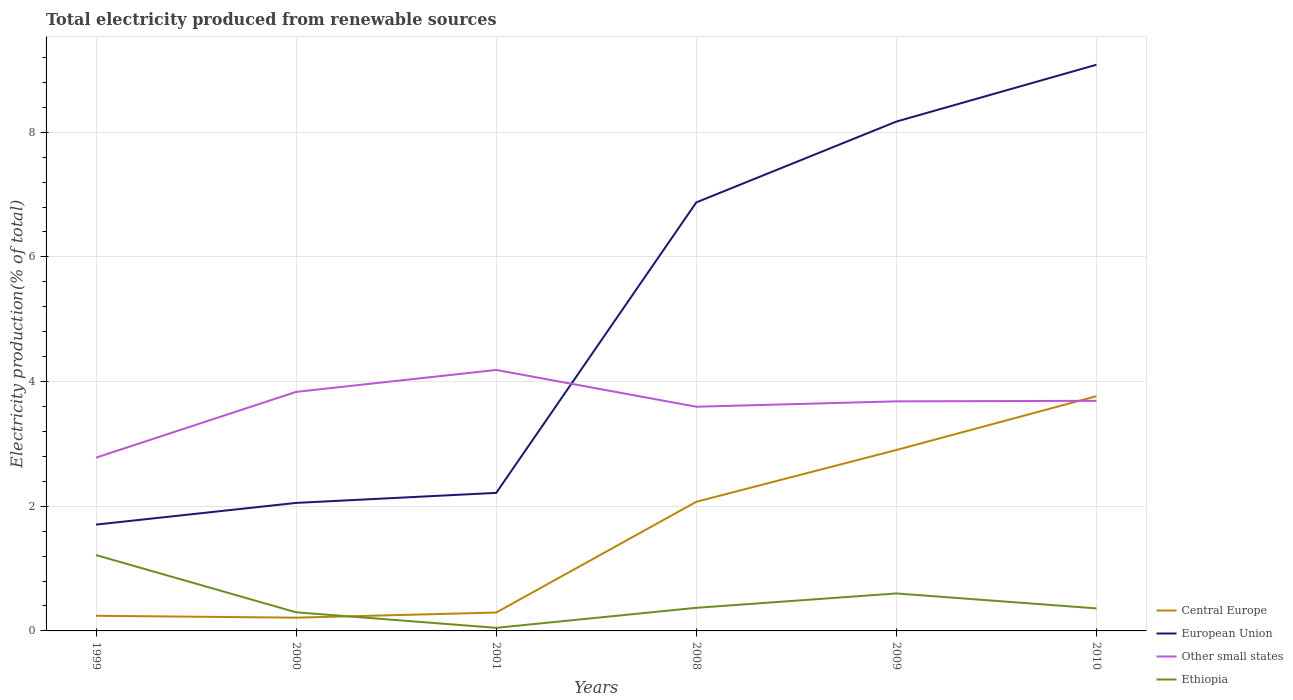How many different coloured lines are there?
Your answer should be compact. 4. Does the line corresponding to Other small states intersect with the line corresponding to Central Europe?
Your answer should be very brief. Yes. Across all years, what is the maximum total electricity produced in Ethiopia?
Keep it short and to the point. 0.05. In which year was the total electricity produced in Ethiopia maximum?
Your response must be concise. 2001. What is the total total electricity produced in Other small states in the graph?
Your answer should be compact. 0.15. What is the difference between the highest and the second highest total electricity produced in Other small states?
Provide a short and direct response. 1.41. What is the difference between the highest and the lowest total electricity produced in European Union?
Provide a succinct answer. 3. Is the total electricity produced in Ethiopia strictly greater than the total electricity produced in European Union over the years?
Offer a terse response. Yes. Are the values on the major ticks of Y-axis written in scientific E-notation?
Provide a short and direct response. No. Does the graph contain grids?
Provide a succinct answer. Yes. What is the title of the graph?
Keep it short and to the point. Total electricity produced from renewable sources. What is the label or title of the X-axis?
Offer a terse response. Years. What is the label or title of the Y-axis?
Keep it short and to the point. Electricity production(% of total). What is the Electricity production(% of total) of Central Europe in 1999?
Offer a very short reply. 0.24. What is the Electricity production(% of total) in European Union in 1999?
Make the answer very short. 1.71. What is the Electricity production(% of total) in Other small states in 1999?
Your response must be concise. 2.78. What is the Electricity production(% of total) in Ethiopia in 1999?
Your answer should be compact. 1.22. What is the Electricity production(% of total) in Central Europe in 2000?
Your answer should be compact. 0.21. What is the Electricity production(% of total) of European Union in 2000?
Your answer should be compact. 2.05. What is the Electricity production(% of total) of Other small states in 2000?
Provide a succinct answer. 3.83. What is the Electricity production(% of total) of Ethiopia in 2000?
Offer a very short reply. 0.3. What is the Electricity production(% of total) in Central Europe in 2001?
Give a very brief answer. 0.29. What is the Electricity production(% of total) of European Union in 2001?
Offer a terse response. 2.21. What is the Electricity production(% of total) of Other small states in 2001?
Your answer should be compact. 4.19. What is the Electricity production(% of total) in Ethiopia in 2001?
Make the answer very short. 0.05. What is the Electricity production(% of total) in Central Europe in 2008?
Provide a short and direct response. 2.07. What is the Electricity production(% of total) in European Union in 2008?
Your response must be concise. 6.87. What is the Electricity production(% of total) in Other small states in 2008?
Give a very brief answer. 3.6. What is the Electricity production(% of total) in Ethiopia in 2008?
Provide a short and direct response. 0.37. What is the Electricity production(% of total) in Central Europe in 2009?
Offer a very short reply. 2.9. What is the Electricity production(% of total) of European Union in 2009?
Give a very brief answer. 8.17. What is the Electricity production(% of total) in Other small states in 2009?
Your response must be concise. 3.68. What is the Electricity production(% of total) in Ethiopia in 2009?
Offer a very short reply. 0.6. What is the Electricity production(% of total) in Central Europe in 2010?
Your response must be concise. 3.77. What is the Electricity production(% of total) in European Union in 2010?
Ensure brevity in your answer.  9.08. What is the Electricity production(% of total) of Other small states in 2010?
Your answer should be compact. 3.69. What is the Electricity production(% of total) of Ethiopia in 2010?
Your answer should be very brief. 0.36. Across all years, what is the maximum Electricity production(% of total) of Central Europe?
Provide a short and direct response. 3.77. Across all years, what is the maximum Electricity production(% of total) in European Union?
Ensure brevity in your answer.  9.08. Across all years, what is the maximum Electricity production(% of total) of Other small states?
Offer a very short reply. 4.19. Across all years, what is the maximum Electricity production(% of total) in Ethiopia?
Give a very brief answer. 1.22. Across all years, what is the minimum Electricity production(% of total) in Central Europe?
Your response must be concise. 0.21. Across all years, what is the minimum Electricity production(% of total) in European Union?
Provide a succinct answer. 1.71. Across all years, what is the minimum Electricity production(% of total) of Other small states?
Ensure brevity in your answer.  2.78. Across all years, what is the minimum Electricity production(% of total) of Ethiopia?
Your response must be concise. 0.05. What is the total Electricity production(% of total) of Central Europe in the graph?
Provide a short and direct response. 9.49. What is the total Electricity production(% of total) of European Union in the graph?
Make the answer very short. 30.1. What is the total Electricity production(% of total) in Other small states in the graph?
Provide a short and direct response. 21.77. What is the total Electricity production(% of total) in Ethiopia in the graph?
Ensure brevity in your answer.  2.9. What is the difference between the Electricity production(% of total) in Central Europe in 1999 and that in 2000?
Provide a short and direct response. 0.03. What is the difference between the Electricity production(% of total) in European Union in 1999 and that in 2000?
Your answer should be compact. -0.35. What is the difference between the Electricity production(% of total) in Other small states in 1999 and that in 2000?
Provide a succinct answer. -1.06. What is the difference between the Electricity production(% of total) of Ethiopia in 1999 and that in 2000?
Ensure brevity in your answer.  0.92. What is the difference between the Electricity production(% of total) in Central Europe in 1999 and that in 2001?
Your response must be concise. -0.05. What is the difference between the Electricity production(% of total) of European Union in 1999 and that in 2001?
Keep it short and to the point. -0.51. What is the difference between the Electricity production(% of total) of Other small states in 1999 and that in 2001?
Your answer should be very brief. -1.41. What is the difference between the Electricity production(% of total) of Ethiopia in 1999 and that in 2001?
Provide a succinct answer. 1.17. What is the difference between the Electricity production(% of total) of Central Europe in 1999 and that in 2008?
Provide a succinct answer. -1.83. What is the difference between the Electricity production(% of total) of European Union in 1999 and that in 2008?
Provide a short and direct response. -5.17. What is the difference between the Electricity production(% of total) of Other small states in 1999 and that in 2008?
Ensure brevity in your answer.  -0.82. What is the difference between the Electricity production(% of total) of Ethiopia in 1999 and that in 2008?
Your response must be concise. 0.85. What is the difference between the Electricity production(% of total) of Central Europe in 1999 and that in 2009?
Make the answer very short. -2.66. What is the difference between the Electricity production(% of total) in European Union in 1999 and that in 2009?
Provide a succinct answer. -6.47. What is the difference between the Electricity production(% of total) of Other small states in 1999 and that in 2009?
Your answer should be very brief. -0.9. What is the difference between the Electricity production(% of total) of Ethiopia in 1999 and that in 2009?
Your answer should be compact. 0.62. What is the difference between the Electricity production(% of total) of Central Europe in 1999 and that in 2010?
Ensure brevity in your answer.  -3.52. What is the difference between the Electricity production(% of total) in European Union in 1999 and that in 2010?
Provide a succinct answer. -7.38. What is the difference between the Electricity production(% of total) of Other small states in 1999 and that in 2010?
Offer a very short reply. -0.91. What is the difference between the Electricity production(% of total) in Ethiopia in 1999 and that in 2010?
Offer a terse response. 0.86. What is the difference between the Electricity production(% of total) in Central Europe in 2000 and that in 2001?
Make the answer very short. -0.08. What is the difference between the Electricity production(% of total) of European Union in 2000 and that in 2001?
Keep it short and to the point. -0.16. What is the difference between the Electricity production(% of total) in Other small states in 2000 and that in 2001?
Offer a very short reply. -0.35. What is the difference between the Electricity production(% of total) of Ethiopia in 2000 and that in 2001?
Offer a terse response. 0.25. What is the difference between the Electricity production(% of total) of Central Europe in 2000 and that in 2008?
Your response must be concise. -1.86. What is the difference between the Electricity production(% of total) of European Union in 2000 and that in 2008?
Keep it short and to the point. -4.82. What is the difference between the Electricity production(% of total) in Other small states in 2000 and that in 2008?
Provide a succinct answer. 0.24. What is the difference between the Electricity production(% of total) of Ethiopia in 2000 and that in 2008?
Give a very brief answer. -0.07. What is the difference between the Electricity production(% of total) of Central Europe in 2000 and that in 2009?
Provide a short and direct response. -2.69. What is the difference between the Electricity production(% of total) of European Union in 2000 and that in 2009?
Provide a succinct answer. -6.12. What is the difference between the Electricity production(% of total) of Other small states in 2000 and that in 2009?
Your answer should be very brief. 0.15. What is the difference between the Electricity production(% of total) in Ethiopia in 2000 and that in 2009?
Offer a terse response. -0.3. What is the difference between the Electricity production(% of total) of Central Europe in 2000 and that in 2010?
Offer a terse response. -3.55. What is the difference between the Electricity production(% of total) in European Union in 2000 and that in 2010?
Offer a terse response. -7.03. What is the difference between the Electricity production(% of total) in Other small states in 2000 and that in 2010?
Keep it short and to the point. 0.14. What is the difference between the Electricity production(% of total) in Ethiopia in 2000 and that in 2010?
Offer a terse response. -0.06. What is the difference between the Electricity production(% of total) in Central Europe in 2001 and that in 2008?
Offer a terse response. -1.78. What is the difference between the Electricity production(% of total) of European Union in 2001 and that in 2008?
Provide a short and direct response. -4.66. What is the difference between the Electricity production(% of total) in Other small states in 2001 and that in 2008?
Offer a terse response. 0.59. What is the difference between the Electricity production(% of total) of Ethiopia in 2001 and that in 2008?
Make the answer very short. -0.32. What is the difference between the Electricity production(% of total) in Central Europe in 2001 and that in 2009?
Keep it short and to the point. -2.61. What is the difference between the Electricity production(% of total) in European Union in 2001 and that in 2009?
Make the answer very short. -5.96. What is the difference between the Electricity production(% of total) in Other small states in 2001 and that in 2009?
Give a very brief answer. 0.5. What is the difference between the Electricity production(% of total) of Ethiopia in 2001 and that in 2009?
Give a very brief answer. -0.55. What is the difference between the Electricity production(% of total) of Central Europe in 2001 and that in 2010?
Offer a very short reply. -3.47. What is the difference between the Electricity production(% of total) of European Union in 2001 and that in 2010?
Your answer should be very brief. -6.87. What is the difference between the Electricity production(% of total) in Other small states in 2001 and that in 2010?
Offer a very short reply. 0.49. What is the difference between the Electricity production(% of total) in Ethiopia in 2001 and that in 2010?
Your response must be concise. -0.31. What is the difference between the Electricity production(% of total) in Central Europe in 2008 and that in 2009?
Your answer should be very brief. -0.83. What is the difference between the Electricity production(% of total) of European Union in 2008 and that in 2009?
Offer a terse response. -1.3. What is the difference between the Electricity production(% of total) in Other small states in 2008 and that in 2009?
Offer a very short reply. -0.09. What is the difference between the Electricity production(% of total) in Ethiopia in 2008 and that in 2009?
Your answer should be compact. -0.23. What is the difference between the Electricity production(% of total) of Central Europe in 2008 and that in 2010?
Keep it short and to the point. -1.69. What is the difference between the Electricity production(% of total) of European Union in 2008 and that in 2010?
Offer a very short reply. -2.21. What is the difference between the Electricity production(% of total) in Other small states in 2008 and that in 2010?
Provide a short and direct response. -0.1. What is the difference between the Electricity production(% of total) of Ethiopia in 2008 and that in 2010?
Give a very brief answer. 0.01. What is the difference between the Electricity production(% of total) of Central Europe in 2009 and that in 2010?
Your response must be concise. -0.86. What is the difference between the Electricity production(% of total) in European Union in 2009 and that in 2010?
Provide a short and direct response. -0.91. What is the difference between the Electricity production(% of total) of Other small states in 2009 and that in 2010?
Offer a terse response. -0.01. What is the difference between the Electricity production(% of total) in Ethiopia in 2009 and that in 2010?
Your response must be concise. 0.24. What is the difference between the Electricity production(% of total) of Central Europe in 1999 and the Electricity production(% of total) of European Union in 2000?
Ensure brevity in your answer.  -1.81. What is the difference between the Electricity production(% of total) in Central Europe in 1999 and the Electricity production(% of total) in Other small states in 2000?
Keep it short and to the point. -3.59. What is the difference between the Electricity production(% of total) of Central Europe in 1999 and the Electricity production(% of total) of Ethiopia in 2000?
Ensure brevity in your answer.  -0.06. What is the difference between the Electricity production(% of total) in European Union in 1999 and the Electricity production(% of total) in Other small states in 2000?
Make the answer very short. -2.13. What is the difference between the Electricity production(% of total) in European Union in 1999 and the Electricity production(% of total) in Ethiopia in 2000?
Offer a terse response. 1.41. What is the difference between the Electricity production(% of total) of Other small states in 1999 and the Electricity production(% of total) of Ethiopia in 2000?
Provide a succinct answer. 2.48. What is the difference between the Electricity production(% of total) of Central Europe in 1999 and the Electricity production(% of total) of European Union in 2001?
Provide a succinct answer. -1.97. What is the difference between the Electricity production(% of total) in Central Europe in 1999 and the Electricity production(% of total) in Other small states in 2001?
Ensure brevity in your answer.  -3.94. What is the difference between the Electricity production(% of total) in Central Europe in 1999 and the Electricity production(% of total) in Ethiopia in 2001?
Your response must be concise. 0.19. What is the difference between the Electricity production(% of total) in European Union in 1999 and the Electricity production(% of total) in Other small states in 2001?
Ensure brevity in your answer.  -2.48. What is the difference between the Electricity production(% of total) of European Union in 1999 and the Electricity production(% of total) of Ethiopia in 2001?
Make the answer very short. 1.66. What is the difference between the Electricity production(% of total) in Other small states in 1999 and the Electricity production(% of total) in Ethiopia in 2001?
Provide a short and direct response. 2.73. What is the difference between the Electricity production(% of total) of Central Europe in 1999 and the Electricity production(% of total) of European Union in 2008?
Offer a very short reply. -6.63. What is the difference between the Electricity production(% of total) in Central Europe in 1999 and the Electricity production(% of total) in Other small states in 2008?
Ensure brevity in your answer.  -3.35. What is the difference between the Electricity production(% of total) of Central Europe in 1999 and the Electricity production(% of total) of Ethiopia in 2008?
Keep it short and to the point. -0.13. What is the difference between the Electricity production(% of total) of European Union in 1999 and the Electricity production(% of total) of Other small states in 2008?
Offer a very short reply. -1.89. What is the difference between the Electricity production(% of total) of European Union in 1999 and the Electricity production(% of total) of Ethiopia in 2008?
Your answer should be compact. 1.33. What is the difference between the Electricity production(% of total) of Other small states in 1999 and the Electricity production(% of total) of Ethiopia in 2008?
Your answer should be very brief. 2.41. What is the difference between the Electricity production(% of total) of Central Europe in 1999 and the Electricity production(% of total) of European Union in 2009?
Provide a succinct answer. -7.93. What is the difference between the Electricity production(% of total) in Central Europe in 1999 and the Electricity production(% of total) in Other small states in 2009?
Provide a succinct answer. -3.44. What is the difference between the Electricity production(% of total) of Central Europe in 1999 and the Electricity production(% of total) of Ethiopia in 2009?
Make the answer very short. -0.36. What is the difference between the Electricity production(% of total) of European Union in 1999 and the Electricity production(% of total) of Other small states in 2009?
Your response must be concise. -1.98. What is the difference between the Electricity production(% of total) of European Union in 1999 and the Electricity production(% of total) of Ethiopia in 2009?
Offer a terse response. 1.1. What is the difference between the Electricity production(% of total) of Other small states in 1999 and the Electricity production(% of total) of Ethiopia in 2009?
Offer a very short reply. 2.18. What is the difference between the Electricity production(% of total) of Central Europe in 1999 and the Electricity production(% of total) of European Union in 2010?
Offer a terse response. -8.84. What is the difference between the Electricity production(% of total) of Central Europe in 1999 and the Electricity production(% of total) of Other small states in 2010?
Keep it short and to the point. -3.45. What is the difference between the Electricity production(% of total) in Central Europe in 1999 and the Electricity production(% of total) in Ethiopia in 2010?
Provide a short and direct response. -0.12. What is the difference between the Electricity production(% of total) in European Union in 1999 and the Electricity production(% of total) in Other small states in 2010?
Provide a succinct answer. -1.99. What is the difference between the Electricity production(% of total) of European Union in 1999 and the Electricity production(% of total) of Ethiopia in 2010?
Provide a succinct answer. 1.34. What is the difference between the Electricity production(% of total) of Other small states in 1999 and the Electricity production(% of total) of Ethiopia in 2010?
Your answer should be compact. 2.42. What is the difference between the Electricity production(% of total) of Central Europe in 2000 and the Electricity production(% of total) of European Union in 2001?
Your answer should be very brief. -2. What is the difference between the Electricity production(% of total) in Central Europe in 2000 and the Electricity production(% of total) in Other small states in 2001?
Offer a very short reply. -3.97. What is the difference between the Electricity production(% of total) in Central Europe in 2000 and the Electricity production(% of total) in Ethiopia in 2001?
Keep it short and to the point. 0.16. What is the difference between the Electricity production(% of total) in European Union in 2000 and the Electricity production(% of total) in Other small states in 2001?
Your answer should be compact. -2.13. What is the difference between the Electricity production(% of total) of European Union in 2000 and the Electricity production(% of total) of Ethiopia in 2001?
Give a very brief answer. 2. What is the difference between the Electricity production(% of total) of Other small states in 2000 and the Electricity production(% of total) of Ethiopia in 2001?
Ensure brevity in your answer.  3.79. What is the difference between the Electricity production(% of total) of Central Europe in 2000 and the Electricity production(% of total) of European Union in 2008?
Keep it short and to the point. -6.66. What is the difference between the Electricity production(% of total) in Central Europe in 2000 and the Electricity production(% of total) in Other small states in 2008?
Make the answer very short. -3.38. What is the difference between the Electricity production(% of total) of Central Europe in 2000 and the Electricity production(% of total) of Ethiopia in 2008?
Make the answer very short. -0.16. What is the difference between the Electricity production(% of total) of European Union in 2000 and the Electricity production(% of total) of Other small states in 2008?
Give a very brief answer. -1.54. What is the difference between the Electricity production(% of total) of European Union in 2000 and the Electricity production(% of total) of Ethiopia in 2008?
Provide a succinct answer. 1.68. What is the difference between the Electricity production(% of total) in Other small states in 2000 and the Electricity production(% of total) in Ethiopia in 2008?
Your answer should be compact. 3.46. What is the difference between the Electricity production(% of total) of Central Europe in 2000 and the Electricity production(% of total) of European Union in 2009?
Make the answer very short. -7.96. What is the difference between the Electricity production(% of total) of Central Europe in 2000 and the Electricity production(% of total) of Other small states in 2009?
Keep it short and to the point. -3.47. What is the difference between the Electricity production(% of total) of Central Europe in 2000 and the Electricity production(% of total) of Ethiopia in 2009?
Offer a very short reply. -0.39. What is the difference between the Electricity production(% of total) of European Union in 2000 and the Electricity production(% of total) of Other small states in 2009?
Ensure brevity in your answer.  -1.63. What is the difference between the Electricity production(% of total) of European Union in 2000 and the Electricity production(% of total) of Ethiopia in 2009?
Your response must be concise. 1.45. What is the difference between the Electricity production(% of total) of Other small states in 2000 and the Electricity production(% of total) of Ethiopia in 2009?
Your answer should be very brief. 3.23. What is the difference between the Electricity production(% of total) in Central Europe in 2000 and the Electricity production(% of total) in European Union in 2010?
Offer a very short reply. -8.87. What is the difference between the Electricity production(% of total) of Central Europe in 2000 and the Electricity production(% of total) of Other small states in 2010?
Offer a very short reply. -3.48. What is the difference between the Electricity production(% of total) of Central Europe in 2000 and the Electricity production(% of total) of Ethiopia in 2010?
Give a very brief answer. -0.15. What is the difference between the Electricity production(% of total) in European Union in 2000 and the Electricity production(% of total) in Other small states in 2010?
Provide a short and direct response. -1.64. What is the difference between the Electricity production(% of total) in European Union in 2000 and the Electricity production(% of total) in Ethiopia in 2010?
Your response must be concise. 1.69. What is the difference between the Electricity production(% of total) of Other small states in 2000 and the Electricity production(% of total) of Ethiopia in 2010?
Provide a short and direct response. 3.47. What is the difference between the Electricity production(% of total) of Central Europe in 2001 and the Electricity production(% of total) of European Union in 2008?
Provide a succinct answer. -6.58. What is the difference between the Electricity production(% of total) in Central Europe in 2001 and the Electricity production(% of total) in Other small states in 2008?
Your answer should be very brief. -3.3. What is the difference between the Electricity production(% of total) in Central Europe in 2001 and the Electricity production(% of total) in Ethiopia in 2008?
Your response must be concise. -0.08. What is the difference between the Electricity production(% of total) of European Union in 2001 and the Electricity production(% of total) of Other small states in 2008?
Your answer should be compact. -1.38. What is the difference between the Electricity production(% of total) of European Union in 2001 and the Electricity production(% of total) of Ethiopia in 2008?
Your response must be concise. 1.84. What is the difference between the Electricity production(% of total) of Other small states in 2001 and the Electricity production(% of total) of Ethiopia in 2008?
Your response must be concise. 3.82. What is the difference between the Electricity production(% of total) in Central Europe in 2001 and the Electricity production(% of total) in European Union in 2009?
Make the answer very short. -7.88. What is the difference between the Electricity production(% of total) of Central Europe in 2001 and the Electricity production(% of total) of Other small states in 2009?
Provide a short and direct response. -3.39. What is the difference between the Electricity production(% of total) in Central Europe in 2001 and the Electricity production(% of total) in Ethiopia in 2009?
Provide a short and direct response. -0.31. What is the difference between the Electricity production(% of total) in European Union in 2001 and the Electricity production(% of total) in Other small states in 2009?
Your response must be concise. -1.47. What is the difference between the Electricity production(% of total) of European Union in 2001 and the Electricity production(% of total) of Ethiopia in 2009?
Your answer should be compact. 1.61. What is the difference between the Electricity production(% of total) in Other small states in 2001 and the Electricity production(% of total) in Ethiopia in 2009?
Make the answer very short. 3.59. What is the difference between the Electricity production(% of total) of Central Europe in 2001 and the Electricity production(% of total) of European Union in 2010?
Ensure brevity in your answer.  -8.79. What is the difference between the Electricity production(% of total) of Central Europe in 2001 and the Electricity production(% of total) of Other small states in 2010?
Give a very brief answer. -3.4. What is the difference between the Electricity production(% of total) of Central Europe in 2001 and the Electricity production(% of total) of Ethiopia in 2010?
Provide a short and direct response. -0.07. What is the difference between the Electricity production(% of total) in European Union in 2001 and the Electricity production(% of total) in Other small states in 2010?
Make the answer very short. -1.48. What is the difference between the Electricity production(% of total) of European Union in 2001 and the Electricity production(% of total) of Ethiopia in 2010?
Offer a terse response. 1.85. What is the difference between the Electricity production(% of total) in Other small states in 2001 and the Electricity production(% of total) in Ethiopia in 2010?
Provide a succinct answer. 3.82. What is the difference between the Electricity production(% of total) in Central Europe in 2008 and the Electricity production(% of total) in European Union in 2009?
Give a very brief answer. -6.1. What is the difference between the Electricity production(% of total) of Central Europe in 2008 and the Electricity production(% of total) of Other small states in 2009?
Ensure brevity in your answer.  -1.61. What is the difference between the Electricity production(% of total) in Central Europe in 2008 and the Electricity production(% of total) in Ethiopia in 2009?
Provide a short and direct response. 1.47. What is the difference between the Electricity production(% of total) in European Union in 2008 and the Electricity production(% of total) in Other small states in 2009?
Your answer should be very brief. 3.19. What is the difference between the Electricity production(% of total) in European Union in 2008 and the Electricity production(% of total) in Ethiopia in 2009?
Your answer should be compact. 6.27. What is the difference between the Electricity production(% of total) of Other small states in 2008 and the Electricity production(% of total) of Ethiopia in 2009?
Offer a terse response. 3. What is the difference between the Electricity production(% of total) of Central Europe in 2008 and the Electricity production(% of total) of European Union in 2010?
Provide a succinct answer. -7.01. What is the difference between the Electricity production(% of total) of Central Europe in 2008 and the Electricity production(% of total) of Other small states in 2010?
Keep it short and to the point. -1.62. What is the difference between the Electricity production(% of total) of Central Europe in 2008 and the Electricity production(% of total) of Ethiopia in 2010?
Your answer should be very brief. 1.71. What is the difference between the Electricity production(% of total) of European Union in 2008 and the Electricity production(% of total) of Other small states in 2010?
Your answer should be very brief. 3.18. What is the difference between the Electricity production(% of total) of European Union in 2008 and the Electricity production(% of total) of Ethiopia in 2010?
Offer a very short reply. 6.51. What is the difference between the Electricity production(% of total) in Other small states in 2008 and the Electricity production(% of total) in Ethiopia in 2010?
Make the answer very short. 3.23. What is the difference between the Electricity production(% of total) of Central Europe in 2009 and the Electricity production(% of total) of European Union in 2010?
Provide a short and direct response. -6.18. What is the difference between the Electricity production(% of total) of Central Europe in 2009 and the Electricity production(% of total) of Other small states in 2010?
Keep it short and to the point. -0.79. What is the difference between the Electricity production(% of total) of Central Europe in 2009 and the Electricity production(% of total) of Ethiopia in 2010?
Offer a very short reply. 2.54. What is the difference between the Electricity production(% of total) in European Union in 2009 and the Electricity production(% of total) in Other small states in 2010?
Your response must be concise. 4.48. What is the difference between the Electricity production(% of total) in European Union in 2009 and the Electricity production(% of total) in Ethiopia in 2010?
Keep it short and to the point. 7.81. What is the difference between the Electricity production(% of total) in Other small states in 2009 and the Electricity production(% of total) in Ethiopia in 2010?
Keep it short and to the point. 3.32. What is the average Electricity production(% of total) in Central Europe per year?
Keep it short and to the point. 1.58. What is the average Electricity production(% of total) in European Union per year?
Provide a short and direct response. 5.02. What is the average Electricity production(% of total) in Other small states per year?
Your answer should be very brief. 3.63. What is the average Electricity production(% of total) in Ethiopia per year?
Offer a terse response. 0.48. In the year 1999, what is the difference between the Electricity production(% of total) in Central Europe and Electricity production(% of total) in European Union?
Provide a succinct answer. -1.46. In the year 1999, what is the difference between the Electricity production(% of total) of Central Europe and Electricity production(% of total) of Other small states?
Give a very brief answer. -2.54. In the year 1999, what is the difference between the Electricity production(% of total) in Central Europe and Electricity production(% of total) in Ethiopia?
Your answer should be very brief. -0.97. In the year 1999, what is the difference between the Electricity production(% of total) of European Union and Electricity production(% of total) of Other small states?
Your answer should be very brief. -1.07. In the year 1999, what is the difference between the Electricity production(% of total) of European Union and Electricity production(% of total) of Ethiopia?
Your answer should be very brief. 0.49. In the year 1999, what is the difference between the Electricity production(% of total) in Other small states and Electricity production(% of total) in Ethiopia?
Your answer should be compact. 1.56. In the year 2000, what is the difference between the Electricity production(% of total) in Central Europe and Electricity production(% of total) in European Union?
Keep it short and to the point. -1.84. In the year 2000, what is the difference between the Electricity production(% of total) in Central Europe and Electricity production(% of total) in Other small states?
Provide a succinct answer. -3.62. In the year 2000, what is the difference between the Electricity production(% of total) of Central Europe and Electricity production(% of total) of Ethiopia?
Make the answer very short. -0.09. In the year 2000, what is the difference between the Electricity production(% of total) in European Union and Electricity production(% of total) in Other small states?
Provide a succinct answer. -1.78. In the year 2000, what is the difference between the Electricity production(% of total) of European Union and Electricity production(% of total) of Ethiopia?
Make the answer very short. 1.75. In the year 2000, what is the difference between the Electricity production(% of total) of Other small states and Electricity production(% of total) of Ethiopia?
Offer a terse response. 3.54. In the year 2001, what is the difference between the Electricity production(% of total) in Central Europe and Electricity production(% of total) in European Union?
Ensure brevity in your answer.  -1.92. In the year 2001, what is the difference between the Electricity production(% of total) in Central Europe and Electricity production(% of total) in Other small states?
Your answer should be very brief. -3.89. In the year 2001, what is the difference between the Electricity production(% of total) in Central Europe and Electricity production(% of total) in Ethiopia?
Your response must be concise. 0.25. In the year 2001, what is the difference between the Electricity production(% of total) in European Union and Electricity production(% of total) in Other small states?
Provide a succinct answer. -1.97. In the year 2001, what is the difference between the Electricity production(% of total) in European Union and Electricity production(% of total) in Ethiopia?
Offer a terse response. 2.16. In the year 2001, what is the difference between the Electricity production(% of total) in Other small states and Electricity production(% of total) in Ethiopia?
Your answer should be very brief. 4.14. In the year 2008, what is the difference between the Electricity production(% of total) of Central Europe and Electricity production(% of total) of European Union?
Your answer should be compact. -4.8. In the year 2008, what is the difference between the Electricity production(% of total) of Central Europe and Electricity production(% of total) of Other small states?
Provide a short and direct response. -1.52. In the year 2008, what is the difference between the Electricity production(% of total) in Central Europe and Electricity production(% of total) in Ethiopia?
Make the answer very short. 1.7. In the year 2008, what is the difference between the Electricity production(% of total) of European Union and Electricity production(% of total) of Other small states?
Your response must be concise. 3.28. In the year 2008, what is the difference between the Electricity production(% of total) of European Union and Electricity production(% of total) of Ethiopia?
Your response must be concise. 6.5. In the year 2008, what is the difference between the Electricity production(% of total) in Other small states and Electricity production(% of total) in Ethiopia?
Your answer should be compact. 3.23. In the year 2009, what is the difference between the Electricity production(% of total) of Central Europe and Electricity production(% of total) of European Union?
Make the answer very short. -5.27. In the year 2009, what is the difference between the Electricity production(% of total) in Central Europe and Electricity production(% of total) in Other small states?
Give a very brief answer. -0.78. In the year 2009, what is the difference between the Electricity production(% of total) in Central Europe and Electricity production(% of total) in Ethiopia?
Provide a short and direct response. 2.3. In the year 2009, what is the difference between the Electricity production(% of total) of European Union and Electricity production(% of total) of Other small states?
Provide a succinct answer. 4.49. In the year 2009, what is the difference between the Electricity production(% of total) in European Union and Electricity production(% of total) in Ethiopia?
Provide a succinct answer. 7.57. In the year 2009, what is the difference between the Electricity production(% of total) of Other small states and Electricity production(% of total) of Ethiopia?
Ensure brevity in your answer.  3.08. In the year 2010, what is the difference between the Electricity production(% of total) in Central Europe and Electricity production(% of total) in European Union?
Your answer should be compact. -5.32. In the year 2010, what is the difference between the Electricity production(% of total) of Central Europe and Electricity production(% of total) of Other small states?
Make the answer very short. 0.07. In the year 2010, what is the difference between the Electricity production(% of total) of Central Europe and Electricity production(% of total) of Ethiopia?
Provide a succinct answer. 3.4. In the year 2010, what is the difference between the Electricity production(% of total) of European Union and Electricity production(% of total) of Other small states?
Make the answer very short. 5.39. In the year 2010, what is the difference between the Electricity production(% of total) of European Union and Electricity production(% of total) of Ethiopia?
Make the answer very short. 8.72. In the year 2010, what is the difference between the Electricity production(% of total) of Other small states and Electricity production(% of total) of Ethiopia?
Make the answer very short. 3.33. What is the ratio of the Electricity production(% of total) in Central Europe in 1999 to that in 2000?
Offer a terse response. 1.14. What is the ratio of the Electricity production(% of total) of European Union in 1999 to that in 2000?
Your answer should be compact. 0.83. What is the ratio of the Electricity production(% of total) in Other small states in 1999 to that in 2000?
Give a very brief answer. 0.72. What is the ratio of the Electricity production(% of total) of Ethiopia in 1999 to that in 2000?
Offer a terse response. 4.07. What is the ratio of the Electricity production(% of total) of Central Europe in 1999 to that in 2001?
Your answer should be compact. 0.82. What is the ratio of the Electricity production(% of total) of European Union in 1999 to that in 2001?
Provide a succinct answer. 0.77. What is the ratio of the Electricity production(% of total) of Other small states in 1999 to that in 2001?
Provide a succinct answer. 0.66. What is the ratio of the Electricity production(% of total) in Ethiopia in 1999 to that in 2001?
Provide a succinct answer. 24.48. What is the ratio of the Electricity production(% of total) in Central Europe in 1999 to that in 2008?
Offer a terse response. 0.12. What is the ratio of the Electricity production(% of total) in European Union in 1999 to that in 2008?
Ensure brevity in your answer.  0.25. What is the ratio of the Electricity production(% of total) of Other small states in 1999 to that in 2008?
Offer a terse response. 0.77. What is the ratio of the Electricity production(% of total) in Ethiopia in 1999 to that in 2008?
Your response must be concise. 3.28. What is the ratio of the Electricity production(% of total) in Central Europe in 1999 to that in 2009?
Offer a terse response. 0.08. What is the ratio of the Electricity production(% of total) of European Union in 1999 to that in 2009?
Make the answer very short. 0.21. What is the ratio of the Electricity production(% of total) of Other small states in 1999 to that in 2009?
Keep it short and to the point. 0.75. What is the ratio of the Electricity production(% of total) of Ethiopia in 1999 to that in 2009?
Give a very brief answer. 2.02. What is the ratio of the Electricity production(% of total) in Central Europe in 1999 to that in 2010?
Your answer should be compact. 0.06. What is the ratio of the Electricity production(% of total) in European Union in 1999 to that in 2010?
Ensure brevity in your answer.  0.19. What is the ratio of the Electricity production(% of total) of Other small states in 1999 to that in 2010?
Ensure brevity in your answer.  0.75. What is the ratio of the Electricity production(% of total) of Ethiopia in 1999 to that in 2010?
Your answer should be compact. 3.37. What is the ratio of the Electricity production(% of total) of Central Europe in 2000 to that in 2001?
Give a very brief answer. 0.72. What is the ratio of the Electricity production(% of total) in European Union in 2000 to that in 2001?
Make the answer very short. 0.93. What is the ratio of the Electricity production(% of total) in Other small states in 2000 to that in 2001?
Provide a short and direct response. 0.92. What is the ratio of the Electricity production(% of total) of Ethiopia in 2000 to that in 2001?
Provide a succinct answer. 6.01. What is the ratio of the Electricity production(% of total) in Central Europe in 2000 to that in 2008?
Make the answer very short. 0.1. What is the ratio of the Electricity production(% of total) of European Union in 2000 to that in 2008?
Keep it short and to the point. 0.3. What is the ratio of the Electricity production(% of total) in Other small states in 2000 to that in 2008?
Your answer should be very brief. 1.07. What is the ratio of the Electricity production(% of total) in Ethiopia in 2000 to that in 2008?
Make the answer very short. 0.81. What is the ratio of the Electricity production(% of total) in Central Europe in 2000 to that in 2009?
Make the answer very short. 0.07. What is the ratio of the Electricity production(% of total) in European Union in 2000 to that in 2009?
Ensure brevity in your answer.  0.25. What is the ratio of the Electricity production(% of total) in Other small states in 2000 to that in 2009?
Your answer should be very brief. 1.04. What is the ratio of the Electricity production(% of total) of Ethiopia in 2000 to that in 2009?
Make the answer very short. 0.5. What is the ratio of the Electricity production(% of total) of Central Europe in 2000 to that in 2010?
Your answer should be very brief. 0.06. What is the ratio of the Electricity production(% of total) in European Union in 2000 to that in 2010?
Offer a very short reply. 0.23. What is the ratio of the Electricity production(% of total) in Other small states in 2000 to that in 2010?
Provide a short and direct response. 1.04. What is the ratio of the Electricity production(% of total) of Ethiopia in 2000 to that in 2010?
Offer a very short reply. 0.83. What is the ratio of the Electricity production(% of total) of Central Europe in 2001 to that in 2008?
Your answer should be compact. 0.14. What is the ratio of the Electricity production(% of total) of European Union in 2001 to that in 2008?
Give a very brief answer. 0.32. What is the ratio of the Electricity production(% of total) in Other small states in 2001 to that in 2008?
Provide a succinct answer. 1.16. What is the ratio of the Electricity production(% of total) of Ethiopia in 2001 to that in 2008?
Offer a terse response. 0.13. What is the ratio of the Electricity production(% of total) in Central Europe in 2001 to that in 2009?
Provide a short and direct response. 0.1. What is the ratio of the Electricity production(% of total) in European Union in 2001 to that in 2009?
Give a very brief answer. 0.27. What is the ratio of the Electricity production(% of total) of Other small states in 2001 to that in 2009?
Make the answer very short. 1.14. What is the ratio of the Electricity production(% of total) of Ethiopia in 2001 to that in 2009?
Your answer should be very brief. 0.08. What is the ratio of the Electricity production(% of total) of Central Europe in 2001 to that in 2010?
Offer a very short reply. 0.08. What is the ratio of the Electricity production(% of total) of European Union in 2001 to that in 2010?
Offer a terse response. 0.24. What is the ratio of the Electricity production(% of total) of Other small states in 2001 to that in 2010?
Offer a terse response. 1.13. What is the ratio of the Electricity production(% of total) in Ethiopia in 2001 to that in 2010?
Your response must be concise. 0.14. What is the ratio of the Electricity production(% of total) in Central Europe in 2008 to that in 2009?
Make the answer very short. 0.71. What is the ratio of the Electricity production(% of total) in European Union in 2008 to that in 2009?
Provide a short and direct response. 0.84. What is the ratio of the Electricity production(% of total) in Other small states in 2008 to that in 2009?
Ensure brevity in your answer.  0.98. What is the ratio of the Electricity production(% of total) of Ethiopia in 2008 to that in 2009?
Provide a short and direct response. 0.62. What is the ratio of the Electricity production(% of total) of Central Europe in 2008 to that in 2010?
Your answer should be very brief. 0.55. What is the ratio of the Electricity production(% of total) of European Union in 2008 to that in 2010?
Your response must be concise. 0.76. What is the ratio of the Electricity production(% of total) in Other small states in 2008 to that in 2010?
Offer a terse response. 0.97. What is the ratio of the Electricity production(% of total) of Ethiopia in 2008 to that in 2010?
Your answer should be compact. 1.03. What is the ratio of the Electricity production(% of total) in Central Europe in 2009 to that in 2010?
Your answer should be very brief. 0.77. What is the ratio of the Electricity production(% of total) in European Union in 2009 to that in 2010?
Offer a terse response. 0.9. What is the ratio of the Electricity production(% of total) in Other small states in 2009 to that in 2010?
Offer a terse response. 1. What is the ratio of the Electricity production(% of total) of Ethiopia in 2009 to that in 2010?
Offer a terse response. 1.66. What is the difference between the highest and the second highest Electricity production(% of total) in Central Europe?
Ensure brevity in your answer.  0.86. What is the difference between the highest and the second highest Electricity production(% of total) of European Union?
Your answer should be compact. 0.91. What is the difference between the highest and the second highest Electricity production(% of total) in Other small states?
Offer a very short reply. 0.35. What is the difference between the highest and the second highest Electricity production(% of total) of Ethiopia?
Make the answer very short. 0.62. What is the difference between the highest and the lowest Electricity production(% of total) of Central Europe?
Provide a succinct answer. 3.55. What is the difference between the highest and the lowest Electricity production(% of total) of European Union?
Make the answer very short. 7.38. What is the difference between the highest and the lowest Electricity production(% of total) of Other small states?
Your answer should be compact. 1.41. What is the difference between the highest and the lowest Electricity production(% of total) of Ethiopia?
Your answer should be very brief. 1.17. 